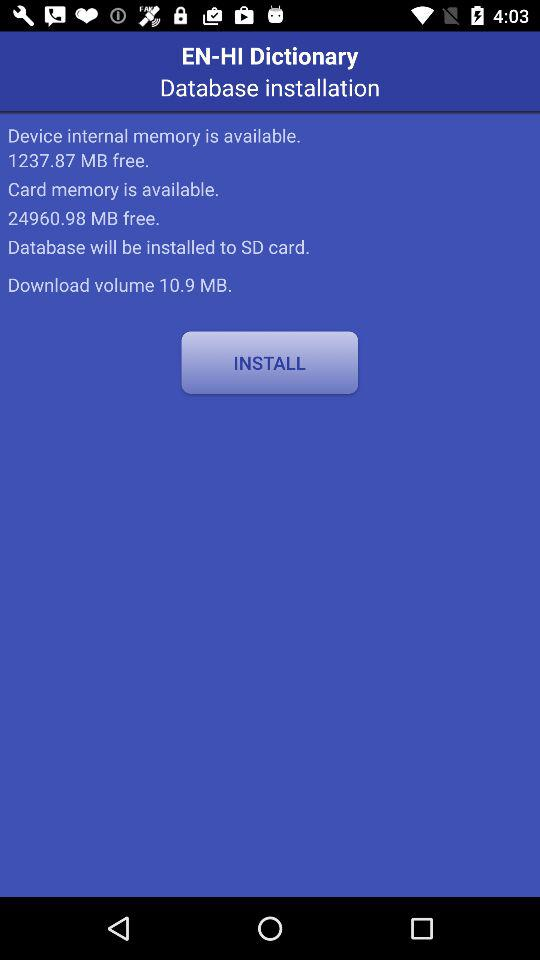How much card memory is free? The free card memory is 24960.98 MB. 